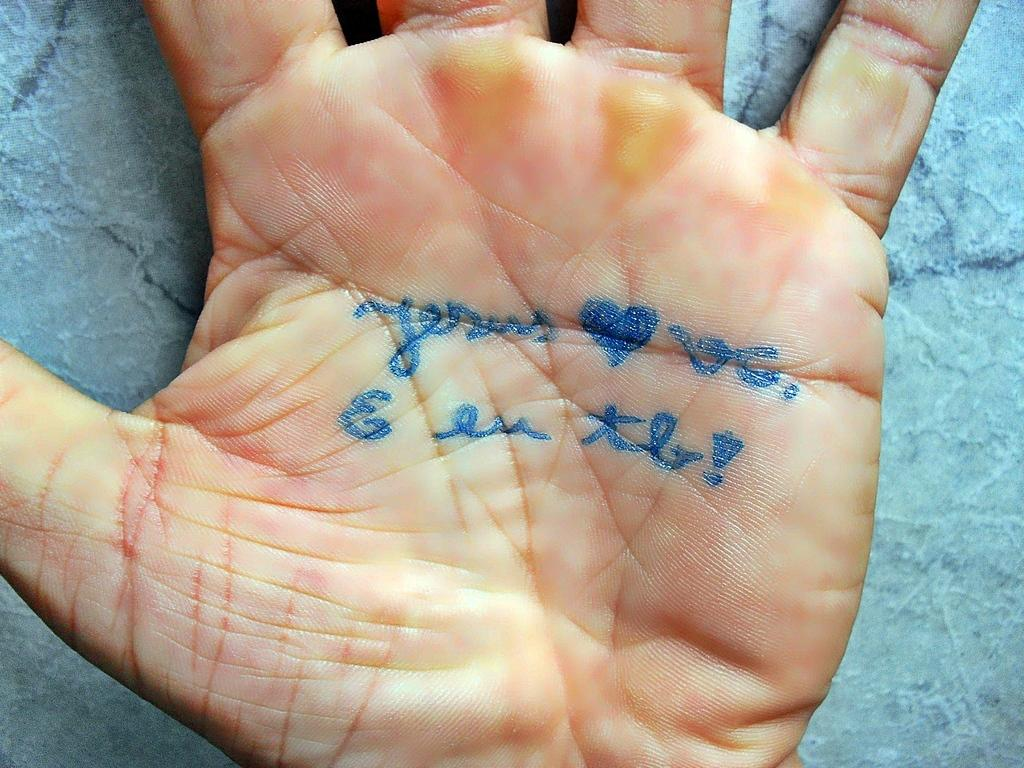What is the main subject of the image? There is a person in the image. What is unique about the person's hand in the image? There is text on the hand of the person. What can be seen at the bottom of the image? There is a floor visible at the bottom of the image. What type of yoke is being used by the person in the image? There is no yoke present in the image; it features a person with text on their hand and a visible floor. How many wrens can be seen in the image? There are no wrens present in the image. 